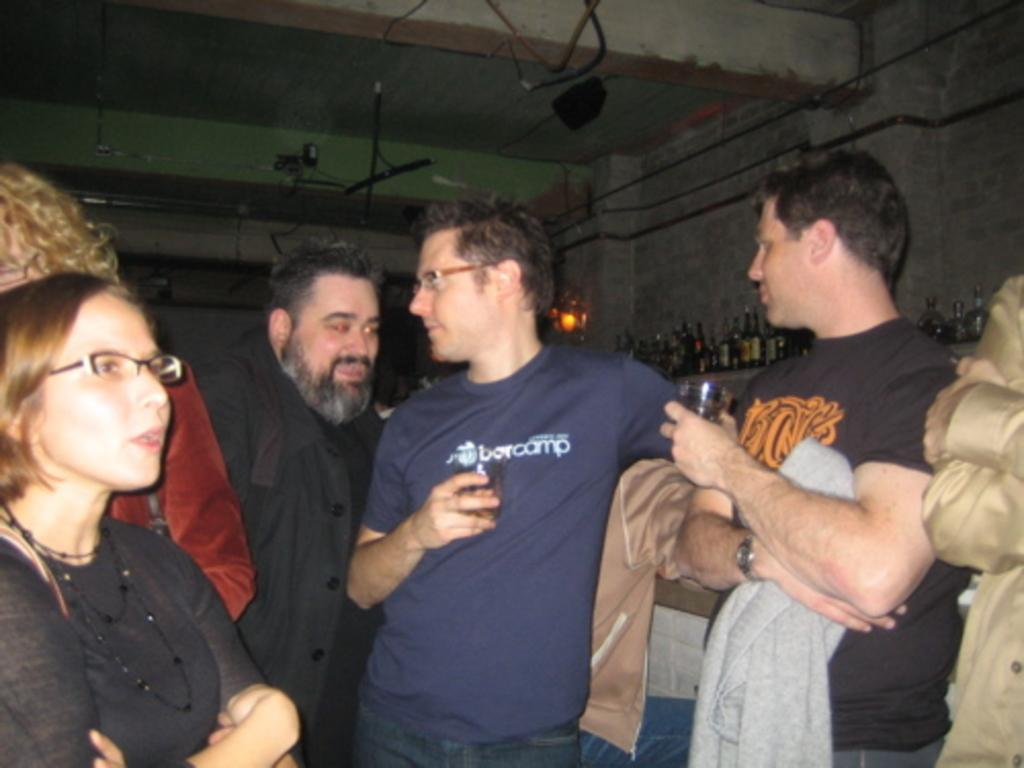What are the people in the image doing? The people in the image are standing. What are some of the people holding? Some of the people are holding glasses. What can be seen in the background of the image? There are bottles placed on a stand and a wall in the background. What type of objects are visible in the image? Pipes are visible in the image. What type of range can be seen in the image? There is no range present in the image. 